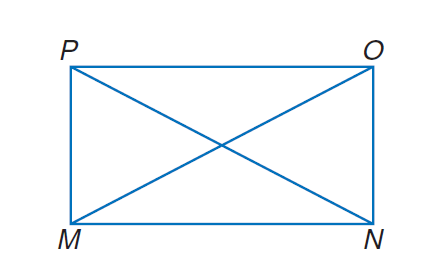Answer the mathemtical geometry problem and directly provide the correct option letter.
Question: Quadrilateral M N O P is a rectangle. If M O = 6 x + 14 and P N = 9 x + 5, find x.
Choices: A: 3 B: 6 C: 9 D: 12 A 